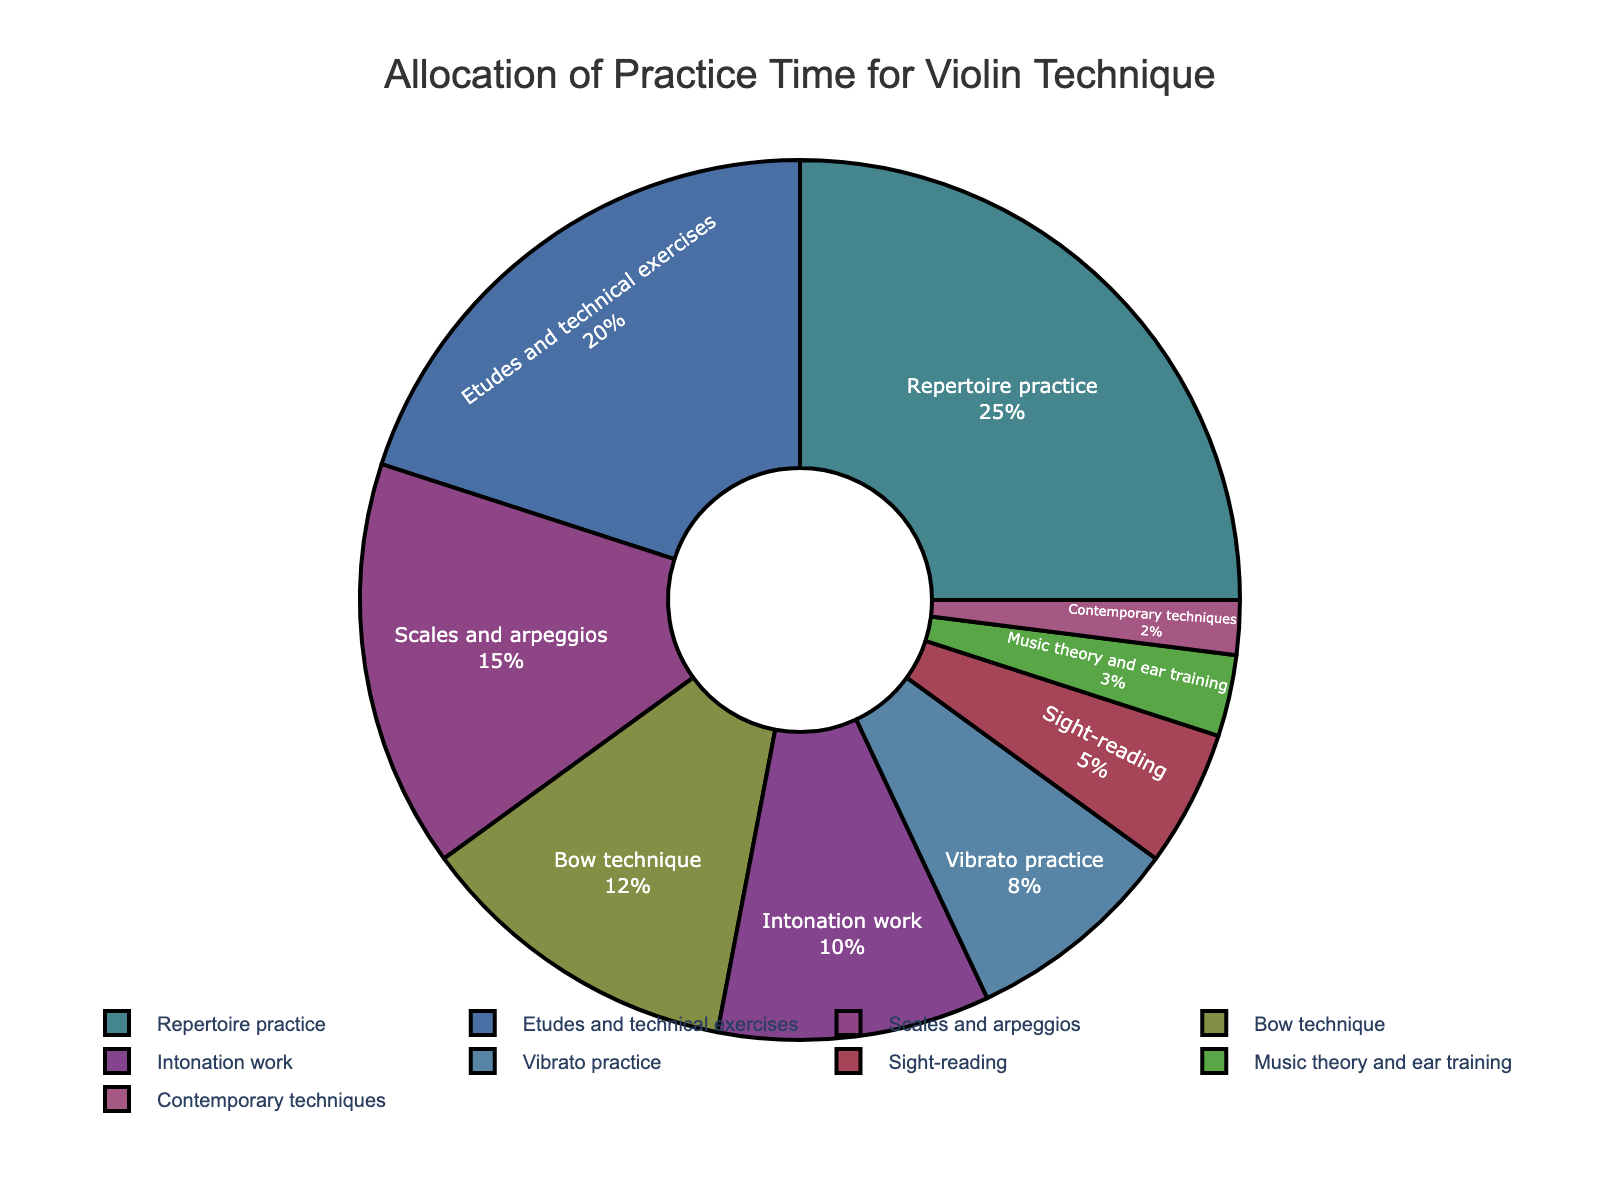What percentage of practice time is allocated to scales and arpeggios? The figure shows a pie chart with labels and percentages. The label "Scales and arpeggios" indicates 15%.
Answer: 15% Which aspect of violin technique is given the most practice time? You can determine the aspect with the highest percentage by looking at the largest segment of the pie chart. "Repertoire practice" has the largest percentage at 25%.
Answer: Repertoire practice What is the combined percentage of practice time allocated to 'Bow technique' and 'Vibrato practice'? Add the percentages for 'Bow technique' (12%) and 'Vibrato practice' (8%). So, 12% + 8% = 20%.
Answer: 20% How much more practice time is allocated to 'Etudes and technical exercises' than to 'Sight-reading'? Subtract the percentage for 'Sight-reading' (5%) from 'Etudes and technical exercises' (20%). So, 20% - 5% = 15%.
Answer: 15% List the aspects that are allocated less than 10% of practice time. Identify the segments of the pie chart with percentages below 10%. These are 'Intonation work' (10%), 'Vibrato practice' (8%), 'Sight-reading' (5%), 'Music theory and ear training' (3%), and 'Contemporary techniques' (2%).
Answer: Intonation work, Vibrato practice, Sight-reading, Music theory and ear training, Contemporary techniques Is the time allocated to 'Repertoire practice' greater than the combined time for 'Scales and arpeggios' and 'Intonation work'? Compare 'Repertoire practice' (25%) with the sum of 'Scales and arpeggios' (15%) and 'Intonation work' (10%). 15% + 10% = 25%, which is equal to the time for 'Repertoire practice'.
Answer: No Which aspect of practice is allocated the least time? Find the segment of the pie chart with the smallest percentage. 'Contemporary techniques' has the smallest percentage at 2%.
Answer: Contemporary techniques 